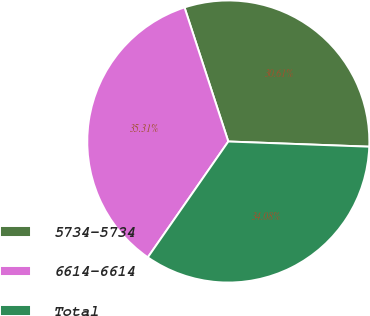Convert chart to OTSL. <chart><loc_0><loc_0><loc_500><loc_500><pie_chart><fcel>5734-5734<fcel>6614-6614<fcel>Total<nl><fcel>30.61%<fcel>35.31%<fcel>34.08%<nl></chart> 